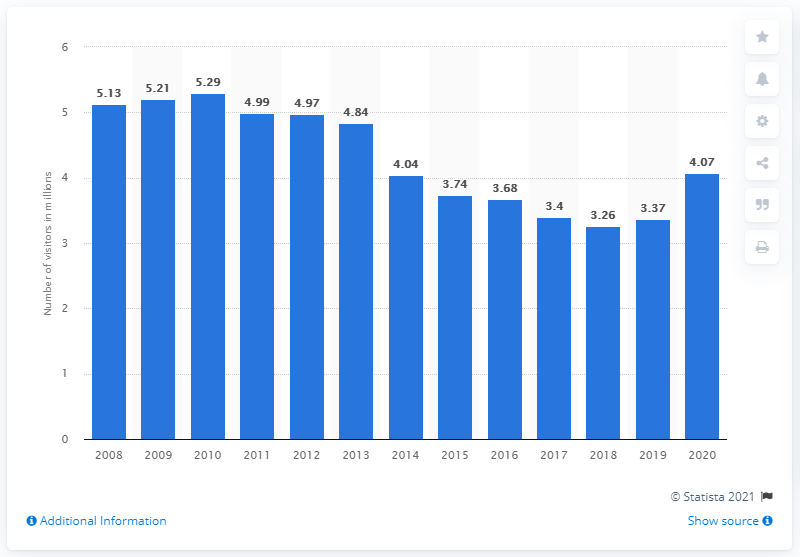Point out several critical features in this image. In 2020, the Delaware Water Gap National Recreation Area was visited by 4,070 people. 